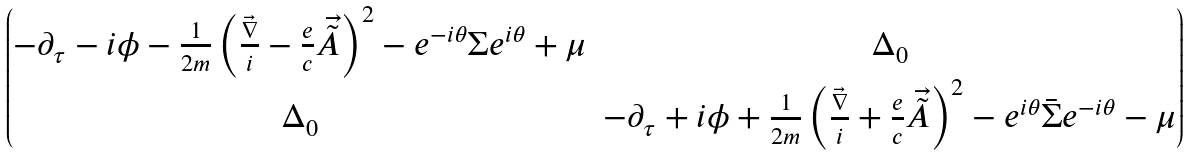<formula> <loc_0><loc_0><loc_500><loc_500>\begin{pmatrix} - \partial _ { \tau } - i \phi - \frac { 1 } { 2 m } \left ( \frac { \vec { \nabla } } { i } - \frac { e } { c } \vec { \tilde { A } } \right ) ^ { 2 } - e ^ { - i \theta } \Sigma e ^ { i \theta } + \mu & \Delta _ { 0 } \\ \Delta _ { 0 } & - \partial _ { \tau } + i \phi + \frac { 1 } { 2 m } \left ( \frac { \vec { \nabla } } { i } + \frac { e } { c } \vec { \tilde { A } } \right ) ^ { 2 } - e ^ { i \theta } \bar { \Sigma } e ^ { - i \theta } - \mu \end{pmatrix}</formula> 